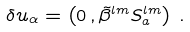Convert formula to latex. <formula><loc_0><loc_0><loc_500><loc_500>\delta u _ { \alpha } = \left ( 0 \, , \tilde { \beta } ^ { l m } S ^ { l m } _ { a } \right ) \, .</formula> 